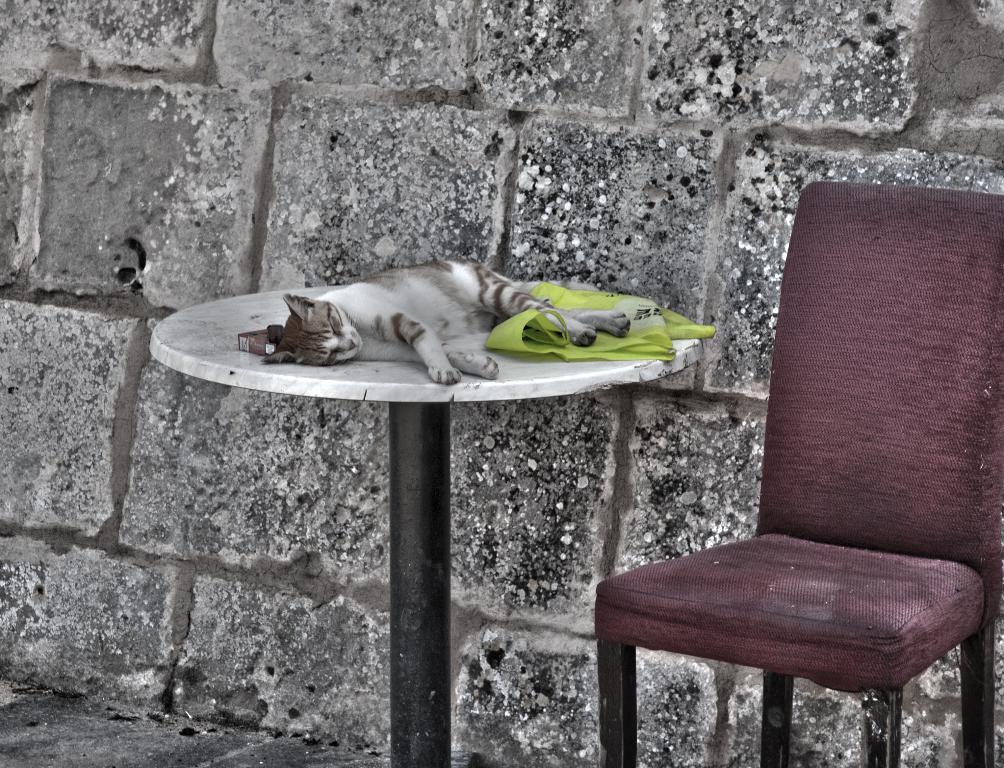What type of animal is in the image? There is a cat in the image. What is the cat doing in the image? The cat is sleeping. Where is the cat located in the image? The cat is on a table. What type of furniture is present in the image? There is a red chair in the image. What type of plant is growing on the cat's head in the image? There is no plant growing on the cat's head in the image; the cat is simply sleeping on the table. 